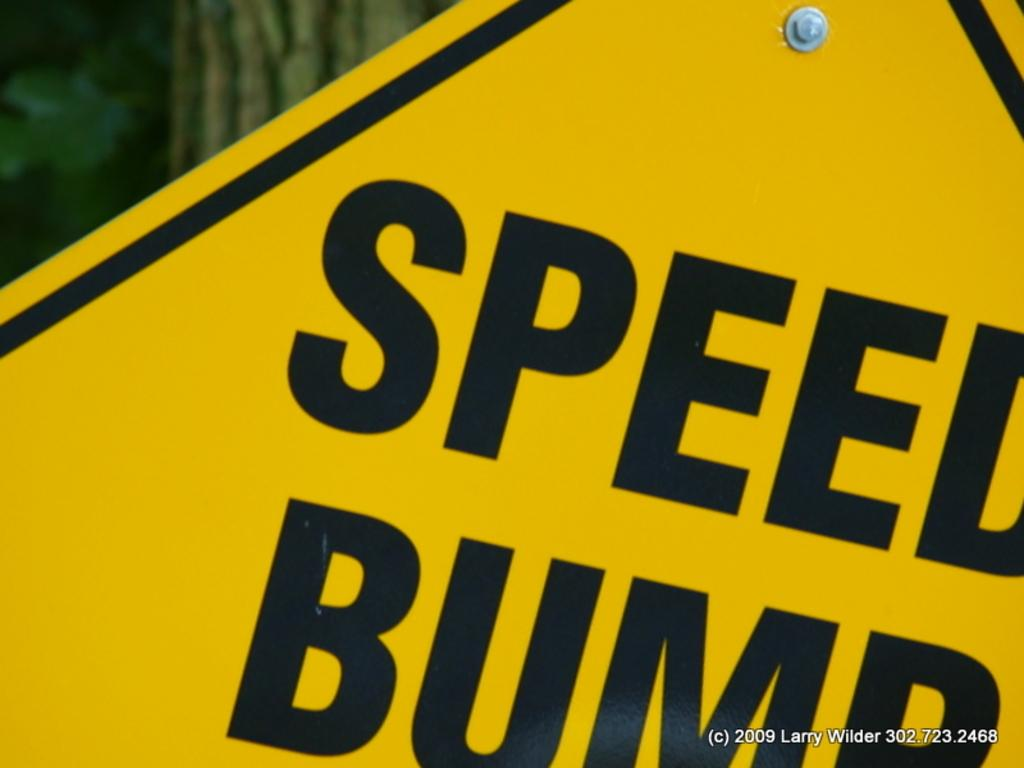<image>
Give a short and clear explanation of the subsequent image. A yellow street sign for a Speed Bump 